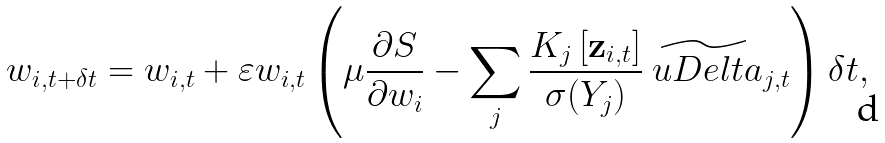<formula> <loc_0><loc_0><loc_500><loc_500>w _ { i , t + \delta t } = w _ { i , t } + \varepsilon w _ { i , t } \left ( \mu \frac { \partial S } { \partial w _ { i } } - \sum _ { j } \frac { K _ { j } \left [ { \mathbf z } _ { i , t } \right ] } { \sigma ( Y _ { j } ) } \widetilde { \ u D e l t a } _ { j , t } \right ) \delta t ,</formula> 